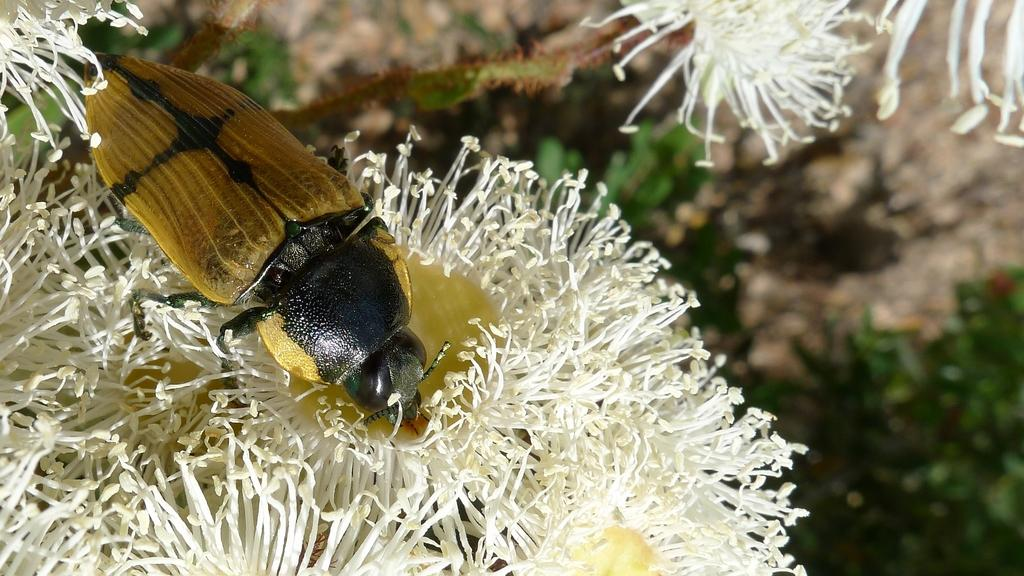What is the main subject of the image? There is a bee in the image. Where is the bee located in the image? The bee is sitting on a flower. What color is the flower the bee is sitting on? The flower is white. What can be seen in the background of the image? There are plants in the background of the image. What type of skate is the bee using to fly in the image? There is no skate present in the image, and bees do not use skates to fly. 